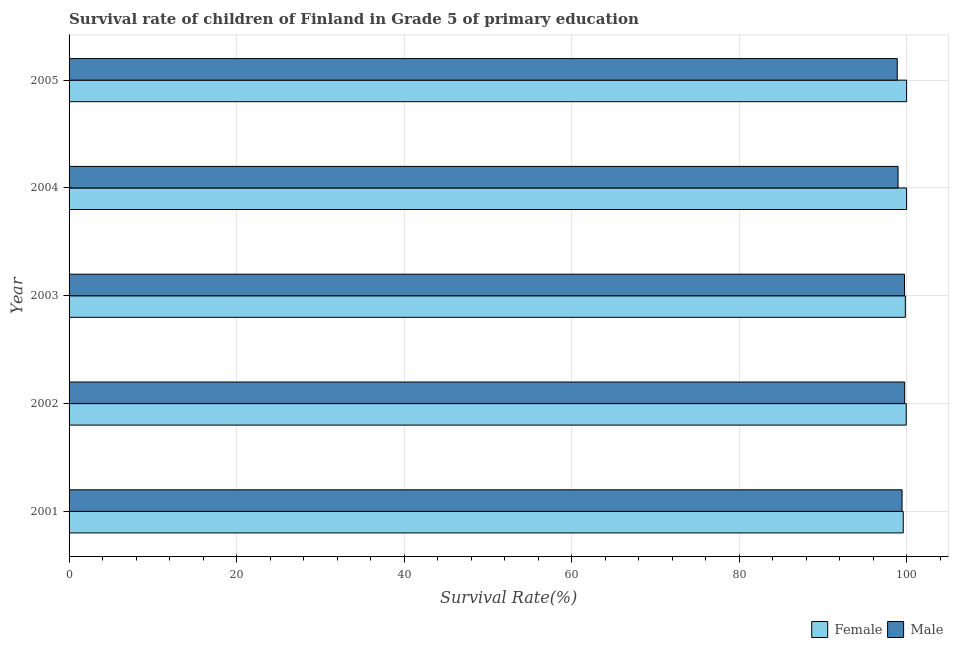How many different coloured bars are there?
Your answer should be compact. 2. How many groups of bars are there?
Your response must be concise. 5. Are the number of bars per tick equal to the number of legend labels?
Your response must be concise. Yes. How many bars are there on the 5th tick from the top?
Provide a succinct answer. 2. How many bars are there on the 1st tick from the bottom?
Keep it short and to the point. 2. What is the survival rate of male students in primary education in 2002?
Your answer should be compact. 99.77. Across all years, what is the maximum survival rate of male students in primary education?
Keep it short and to the point. 99.77. Across all years, what is the minimum survival rate of female students in primary education?
Offer a terse response. 99.6. In which year was the survival rate of male students in primary education maximum?
Offer a terse response. 2002. In which year was the survival rate of female students in primary education minimum?
Give a very brief answer. 2001. What is the total survival rate of male students in primary education in the graph?
Provide a short and direct response. 496.83. What is the difference between the survival rate of male students in primary education in 2004 and that in 2005?
Keep it short and to the point. 0.1. What is the difference between the survival rate of female students in primary education in 2002 and the survival rate of male students in primary education in 2005?
Your answer should be very brief. 1.08. What is the average survival rate of male students in primary education per year?
Offer a very short reply. 99.37. In the year 2003, what is the difference between the survival rate of male students in primary education and survival rate of female students in primary education?
Give a very brief answer. -0.1. Is the survival rate of male students in primary education in 2001 less than that in 2002?
Make the answer very short. Yes. What is the difference between the highest and the second highest survival rate of female students in primary education?
Your answer should be very brief. 0. What is the difference between the highest and the lowest survival rate of male students in primary education?
Make the answer very short. 0.89. In how many years, is the survival rate of female students in primary education greater than the average survival rate of female students in primary education taken over all years?
Offer a terse response. 3. How many bars are there?
Your response must be concise. 10. Are all the bars in the graph horizontal?
Offer a very short reply. Yes. How many years are there in the graph?
Give a very brief answer. 5. Does the graph contain any zero values?
Your answer should be very brief. No. How many legend labels are there?
Your response must be concise. 2. What is the title of the graph?
Keep it short and to the point. Survival rate of children of Finland in Grade 5 of primary education. What is the label or title of the X-axis?
Ensure brevity in your answer.  Survival Rate(%). What is the label or title of the Y-axis?
Give a very brief answer. Year. What is the Survival Rate(%) in Female in 2001?
Your answer should be compact. 99.6. What is the Survival Rate(%) in Male in 2001?
Offer a very short reply. 99.46. What is the Survival Rate(%) in Female in 2002?
Your response must be concise. 99.96. What is the Survival Rate(%) of Male in 2002?
Provide a short and direct response. 99.77. What is the Survival Rate(%) in Female in 2003?
Offer a very short reply. 99.85. What is the Survival Rate(%) in Male in 2003?
Ensure brevity in your answer.  99.75. What is the Survival Rate(%) in Female in 2004?
Keep it short and to the point. 100. What is the Survival Rate(%) in Male in 2004?
Provide a succinct answer. 98.98. What is the Survival Rate(%) of Male in 2005?
Give a very brief answer. 98.88. Across all years, what is the maximum Survival Rate(%) of Male?
Give a very brief answer. 99.77. Across all years, what is the minimum Survival Rate(%) in Female?
Offer a very short reply. 99.6. Across all years, what is the minimum Survival Rate(%) in Male?
Your response must be concise. 98.88. What is the total Survival Rate(%) in Female in the graph?
Provide a short and direct response. 499.4. What is the total Survival Rate(%) in Male in the graph?
Give a very brief answer. 496.83. What is the difference between the Survival Rate(%) of Female in 2001 and that in 2002?
Your response must be concise. -0.36. What is the difference between the Survival Rate(%) in Male in 2001 and that in 2002?
Your answer should be very brief. -0.32. What is the difference between the Survival Rate(%) of Female in 2001 and that in 2003?
Provide a succinct answer. -0.25. What is the difference between the Survival Rate(%) of Male in 2001 and that in 2003?
Your response must be concise. -0.29. What is the difference between the Survival Rate(%) in Female in 2001 and that in 2004?
Offer a very short reply. -0.4. What is the difference between the Survival Rate(%) of Male in 2001 and that in 2004?
Make the answer very short. 0.48. What is the difference between the Survival Rate(%) of Female in 2001 and that in 2005?
Your answer should be compact. -0.4. What is the difference between the Survival Rate(%) of Male in 2001 and that in 2005?
Provide a succinct answer. 0.57. What is the difference between the Survival Rate(%) of Female in 2002 and that in 2003?
Make the answer very short. 0.11. What is the difference between the Survival Rate(%) in Male in 2002 and that in 2003?
Provide a short and direct response. 0.02. What is the difference between the Survival Rate(%) in Female in 2002 and that in 2004?
Keep it short and to the point. -0.04. What is the difference between the Survival Rate(%) of Male in 2002 and that in 2004?
Offer a very short reply. 0.79. What is the difference between the Survival Rate(%) of Female in 2002 and that in 2005?
Keep it short and to the point. -0.04. What is the difference between the Survival Rate(%) in Male in 2002 and that in 2005?
Provide a succinct answer. 0.89. What is the difference between the Survival Rate(%) in Female in 2003 and that in 2004?
Your response must be concise. -0.15. What is the difference between the Survival Rate(%) in Male in 2003 and that in 2004?
Offer a very short reply. 0.77. What is the difference between the Survival Rate(%) of Female in 2003 and that in 2005?
Keep it short and to the point. -0.15. What is the difference between the Survival Rate(%) in Male in 2003 and that in 2005?
Keep it short and to the point. 0.87. What is the difference between the Survival Rate(%) in Male in 2004 and that in 2005?
Provide a succinct answer. 0.1. What is the difference between the Survival Rate(%) in Female in 2001 and the Survival Rate(%) in Male in 2002?
Give a very brief answer. -0.17. What is the difference between the Survival Rate(%) in Female in 2001 and the Survival Rate(%) in Male in 2003?
Your answer should be very brief. -0.15. What is the difference between the Survival Rate(%) in Female in 2001 and the Survival Rate(%) in Male in 2004?
Make the answer very short. 0.62. What is the difference between the Survival Rate(%) of Female in 2001 and the Survival Rate(%) of Male in 2005?
Offer a very short reply. 0.72. What is the difference between the Survival Rate(%) in Female in 2002 and the Survival Rate(%) in Male in 2003?
Offer a terse response. 0.21. What is the difference between the Survival Rate(%) of Female in 2002 and the Survival Rate(%) of Male in 2004?
Your response must be concise. 0.98. What is the difference between the Survival Rate(%) of Female in 2002 and the Survival Rate(%) of Male in 2005?
Offer a terse response. 1.08. What is the difference between the Survival Rate(%) in Female in 2003 and the Survival Rate(%) in Male in 2004?
Provide a short and direct response. 0.87. What is the difference between the Survival Rate(%) of Female in 2003 and the Survival Rate(%) of Male in 2005?
Your answer should be compact. 0.97. What is the difference between the Survival Rate(%) of Female in 2004 and the Survival Rate(%) of Male in 2005?
Ensure brevity in your answer.  1.12. What is the average Survival Rate(%) in Female per year?
Ensure brevity in your answer.  99.88. What is the average Survival Rate(%) in Male per year?
Your answer should be very brief. 99.37. In the year 2001, what is the difference between the Survival Rate(%) of Female and Survival Rate(%) of Male?
Provide a short and direct response. 0.14. In the year 2002, what is the difference between the Survival Rate(%) in Female and Survival Rate(%) in Male?
Offer a terse response. 0.19. In the year 2003, what is the difference between the Survival Rate(%) of Female and Survival Rate(%) of Male?
Keep it short and to the point. 0.1. In the year 2005, what is the difference between the Survival Rate(%) of Female and Survival Rate(%) of Male?
Your answer should be compact. 1.12. What is the ratio of the Survival Rate(%) in Female in 2001 to that in 2002?
Your answer should be very brief. 1. What is the ratio of the Survival Rate(%) of Male in 2001 to that in 2003?
Your response must be concise. 1. What is the ratio of the Survival Rate(%) in Female in 2001 to that in 2004?
Give a very brief answer. 1. What is the ratio of the Survival Rate(%) of Female in 2002 to that in 2003?
Offer a terse response. 1. What is the ratio of the Survival Rate(%) of Male in 2002 to that in 2003?
Give a very brief answer. 1. What is the ratio of the Survival Rate(%) in Female in 2002 to that in 2004?
Ensure brevity in your answer.  1. What is the ratio of the Survival Rate(%) in Male in 2002 to that in 2004?
Your answer should be compact. 1.01. What is the ratio of the Survival Rate(%) in Female in 2002 to that in 2005?
Your answer should be very brief. 1. What is the ratio of the Survival Rate(%) in Male in 2002 to that in 2005?
Your answer should be compact. 1.01. What is the ratio of the Survival Rate(%) of Male in 2003 to that in 2004?
Provide a succinct answer. 1.01. What is the ratio of the Survival Rate(%) of Female in 2003 to that in 2005?
Your response must be concise. 1. What is the ratio of the Survival Rate(%) in Male in 2003 to that in 2005?
Provide a succinct answer. 1.01. What is the difference between the highest and the second highest Survival Rate(%) in Female?
Ensure brevity in your answer.  0. What is the difference between the highest and the second highest Survival Rate(%) in Male?
Keep it short and to the point. 0.02. What is the difference between the highest and the lowest Survival Rate(%) of Female?
Your response must be concise. 0.4. What is the difference between the highest and the lowest Survival Rate(%) of Male?
Provide a short and direct response. 0.89. 